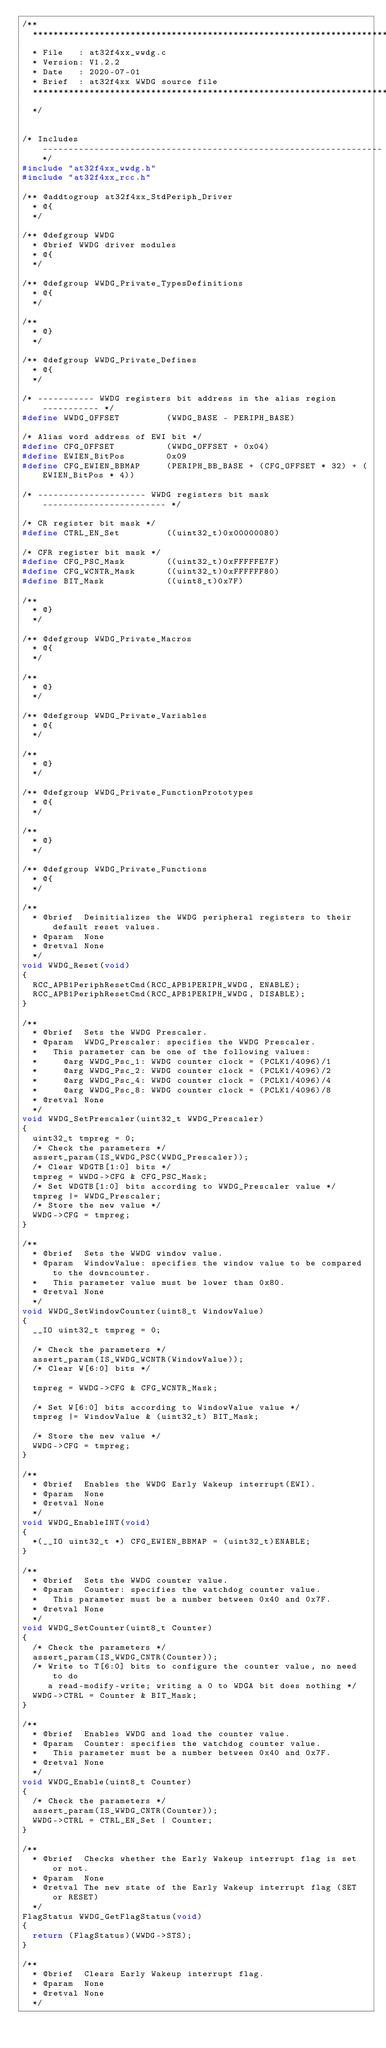<code> <loc_0><loc_0><loc_500><loc_500><_C_>/**
  **************************************************************************
  * File   : at32f4xx_wwdg.c
  * Version: V1.2.2
  * Date   : 2020-07-01
  * Brief  : at32f4xx WWDG source file
  **************************************************************************
  */


/* Includes ------------------------------------------------------------------*/
#include "at32f4xx_wwdg.h"
#include "at32f4xx_rcc.h"

/** @addtogroup at32f4xx_StdPeriph_Driver
  * @{
  */

/** @defgroup WWDG
  * @brief WWDG driver modules
  * @{
  */

/** @defgroup WWDG_Private_TypesDefinitions
  * @{
  */

/**
  * @}
  */

/** @defgroup WWDG_Private_Defines
  * @{
  */

/* ----------- WWDG registers bit address in the alias region ----------- */
#define WWDG_OFFSET         (WWDG_BASE - PERIPH_BASE)

/* Alias word address of EWI bit */
#define CFG_OFFSET          (WWDG_OFFSET + 0x04)
#define EWIEN_BitPos        0x09
#define CFG_EWIEN_BBMAP     (PERIPH_BB_BASE + (CFG_OFFSET * 32) + (EWIEN_BitPos * 4))

/* --------------------- WWDG registers bit mask ------------------------ */

/* CR register bit mask */
#define CTRL_EN_Set         ((uint32_t)0x00000080)

/* CFR register bit mask */
#define CFG_PSC_Mask        ((uint32_t)0xFFFFFE7F)
#define CFG_WCNTR_Mask      ((uint32_t)0xFFFFFF80)
#define BIT_Mask            ((uint8_t)0x7F)

/**
  * @}
  */

/** @defgroup WWDG_Private_Macros
  * @{
  */

/**
  * @}
  */

/** @defgroup WWDG_Private_Variables
  * @{
  */

/**
  * @}
  */

/** @defgroup WWDG_Private_FunctionPrototypes
  * @{
  */

/**
  * @}
  */

/** @defgroup WWDG_Private_Functions
  * @{
  */

/**
  * @brief  Deinitializes the WWDG peripheral registers to their default reset values.
  * @param  None
  * @retval None
  */
void WWDG_Reset(void)
{
  RCC_APB1PeriphResetCmd(RCC_APB1PERIPH_WWDG, ENABLE);
  RCC_APB1PeriphResetCmd(RCC_APB1PERIPH_WWDG, DISABLE);
}

/**
  * @brief  Sets the WWDG Prescaler.
  * @param  WWDG_Prescaler: specifies the WWDG Prescaler.
  *   This parameter can be one of the following values:
  *     @arg WWDG_Psc_1: WWDG counter clock = (PCLK1/4096)/1
  *     @arg WWDG_Psc_2: WWDG counter clock = (PCLK1/4096)/2
  *     @arg WWDG_Psc_4: WWDG counter clock = (PCLK1/4096)/4
  *     @arg WWDG_Psc_8: WWDG counter clock = (PCLK1/4096)/8
  * @retval None
  */
void WWDG_SetPrescaler(uint32_t WWDG_Prescaler)
{
  uint32_t tmpreg = 0;
  /* Check the parameters */
  assert_param(IS_WWDG_PSC(WWDG_Prescaler));
  /* Clear WDGTB[1:0] bits */
  tmpreg = WWDG->CFG & CFG_PSC_Mask;
  /* Set WDGTB[1:0] bits according to WWDG_Prescaler value */
  tmpreg |= WWDG_Prescaler;
  /* Store the new value */
  WWDG->CFG = tmpreg;
}

/**
  * @brief  Sets the WWDG window value.
  * @param  WindowValue: specifies the window value to be compared to the downcounter.
  *   This parameter value must be lower than 0x80.
  * @retval None
  */
void WWDG_SetWindowCounter(uint8_t WindowValue)
{
  __IO uint32_t tmpreg = 0;

  /* Check the parameters */
  assert_param(IS_WWDG_WCNTR(WindowValue));
  /* Clear W[6:0] bits */

  tmpreg = WWDG->CFG & CFG_WCNTR_Mask;

  /* Set W[6:0] bits according to WindowValue value */
  tmpreg |= WindowValue & (uint32_t) BIT_Mask;

  /* Store the new value */
  WWDG->CFG = tmpreg;
}

/**
  * @brief  Enables the WWDG Early Wakeup interrupt(EWI).
  * @param  None
  * @retval None
  */
void WWDG_EnableINT(void)
{
  *(__IO uint32_t *) CFG_EWIEN_BBMAP = (uint32_t)ENABLE;
}

/**
  * @brief  Sets the WWDG counter value.
  * @param  Counter: specifies the watchdog counter value.
  *   This parameter must be a number between 0x40 and 0x7F.
  * @retval None
  */
void WWDG_SetCounter(uint8_t Counter)
{
  /* Check the parameters */
  assert_param(IS_WWDG_CNTR(Counter));
  /* Write to T[6:0] bits to configure the counter value, no need to do
     a read-modify-write; writing a 0 to WDGA bit does nothing */
  WWDG->CTRL = Counter & BIT_Mask;
}

/**
  * @brief  Enables WWDG and load the counter value.
  * @param  Counter: specifies the watchdog counter value.
  *   This parameter must be a number between 0x40 and 0x7F.
  * @retval None
  */
void WWDG_Enable(uint8_t Counter)
{
  /* Check the parameters */
  assert_param(IS_WWDG_CNTR(Counter));
  WWDG->CTRL = CTRL_EN_Set | Counter;
}

/**
  * @brief  Checks whether the Early Wakeup interrupt flag is set or not.
  * @param  None
  * @retval The new state of the Early Wakeup interrupt flag (SET or RESET)
  */
FlagStatus WWDG_GetFlagStatus(void)
{
  return (FlagStatus)(WWDG->STS);
}

/**
  * @brief  Clears Early Wakeup interrupt flag.
  * @param  None
  * @retval None
  */</code> 